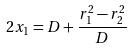<formula> <loc_0><loc_0><loc_500><loc_500>2 x _ { 1 } = D + \frac { r _ { 1 } ^ { 2 } - r _ { 2 } ^ { 2 } } { D }</formula> 